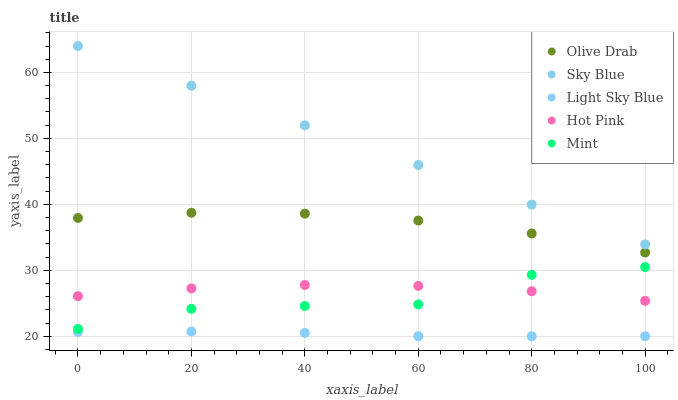Does Light Sky Blue have the minimum area under the curve?
Answer yes or no. Yes. Does Sky Blue have the maximum area under the curve?
Answer yes or no. Yes. Does Mint have the minimum area under the curve?
Answer yes or no. No. Does Mint have the maximum area under the curve?
Answer yes or no. No. Is Sky Blue the smoothest?
Answer yes or no. Yes. Is Mint the roughest?
Answer yes or no. Yes. Is Light Sky Blue the smoothest?
Answer yes or no. No. Is Light Sky Blue the roughest?
Answer yes or no. No. Does Light Sky Blue have the lowest value?
Answer yes or no. Yes. Does Mint have the lowest value?
Answer yes or no. No. Does Sky Blue have the highest value?
Answer yes or no. Yes. Does Mint have the highest value?
Answer yes or no. No. Is Mint less than Sky Blue?
Answer yes or no. Yes. Is Olive Drab greater than Light Sky Blue?
Answer yes or no. Yes. Does Mint intersect Hot Pink?
Answer yes or no. Yes. Is Mint less than Hot Pink?
Answer yes or no. No. Is Mint greater than Hot Pink?
Answer yes or no. No. Does Mint intersect Sky Blue?
Answer yes or no. No. 